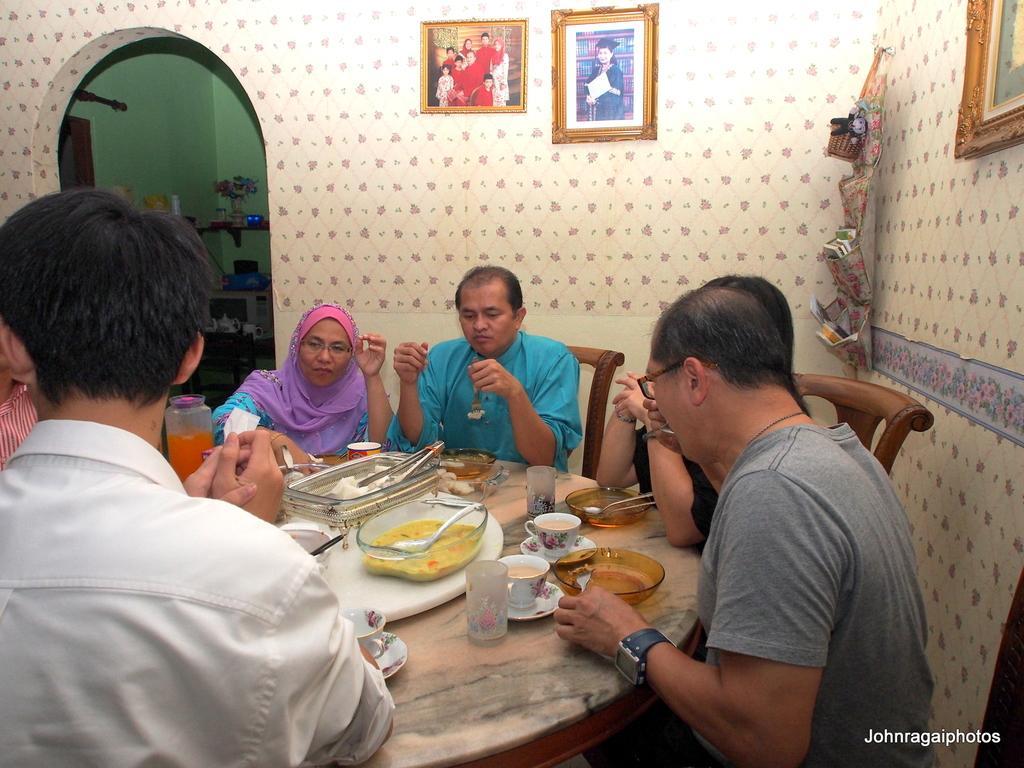How would you summarize this image in a sentence or two? On the background we can see photo frames over a decorative wall. Here we can see a flower vase in a rack. Here we can see all the persons sitting on chairs in front of a dining table and on the table we can see plates, spoons, containers with food items, cup, saucer. 